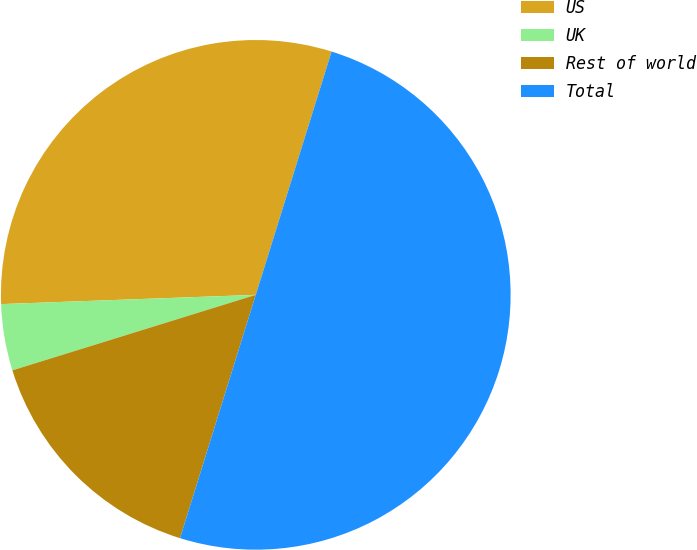Convert chart to OTSL. <chart><loc_0><loc_0><loc_500><loc_500><pie_chart><fcel>US<fcel>UK<fcel>Rest of world<fcel>Total<nl><fcel>30.39%<fcel>4.21%<fcel>15.41%<fcel>50.0%<nl></chart> 